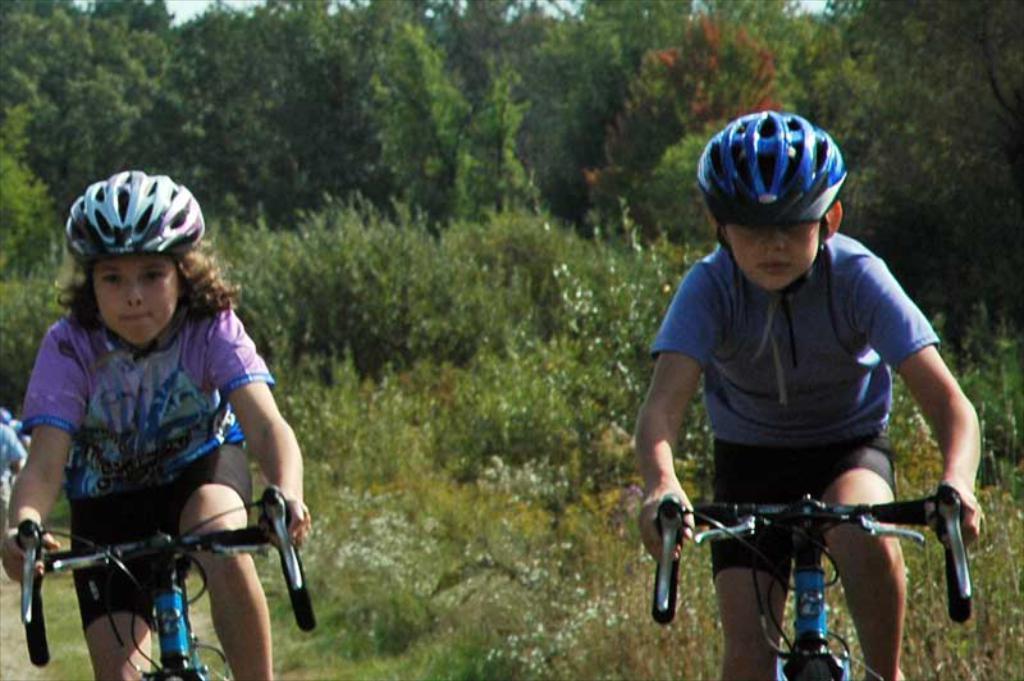In one or two sentences, can you explain what this image depicts? In this image we can see two children are wearing helmets and riding the bicycle. There are trees in the background. 